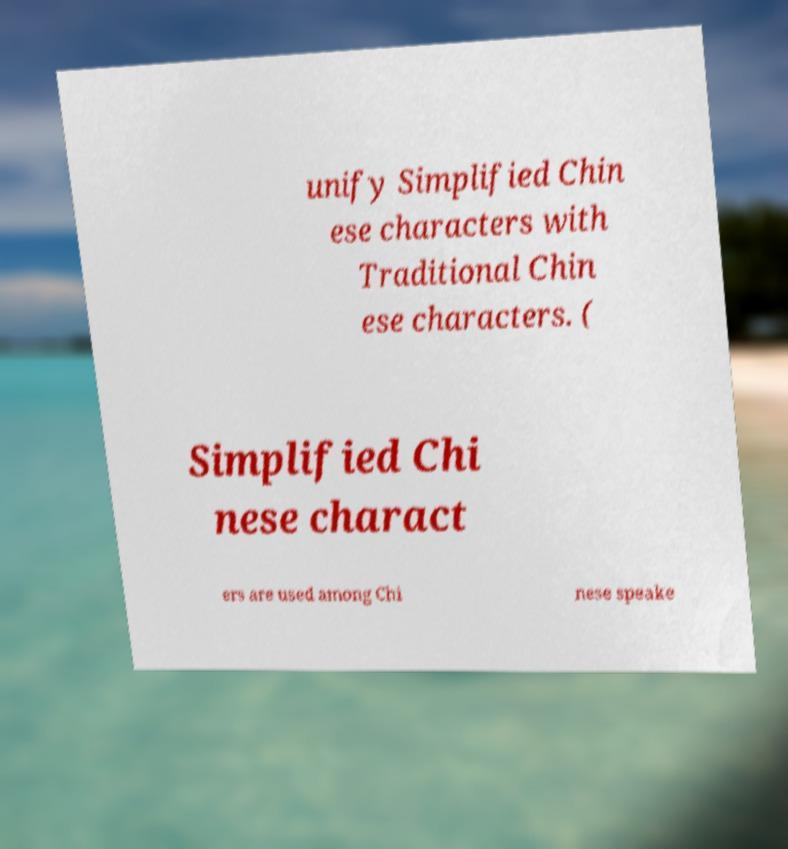Please read and relay the text visible in this image. What does it say? unify Simplified Chin ese characters with Traditional Chin ese characters. ( Simplified Chi nese charact ers are used among Chi nese speake 